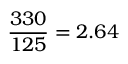Convert formula to latex. <formula><loc_0><loc_0><loc_500><loc_500>\frac { 3 3 0 } { 1 2 5 } = 2 . 6 4</formula> 